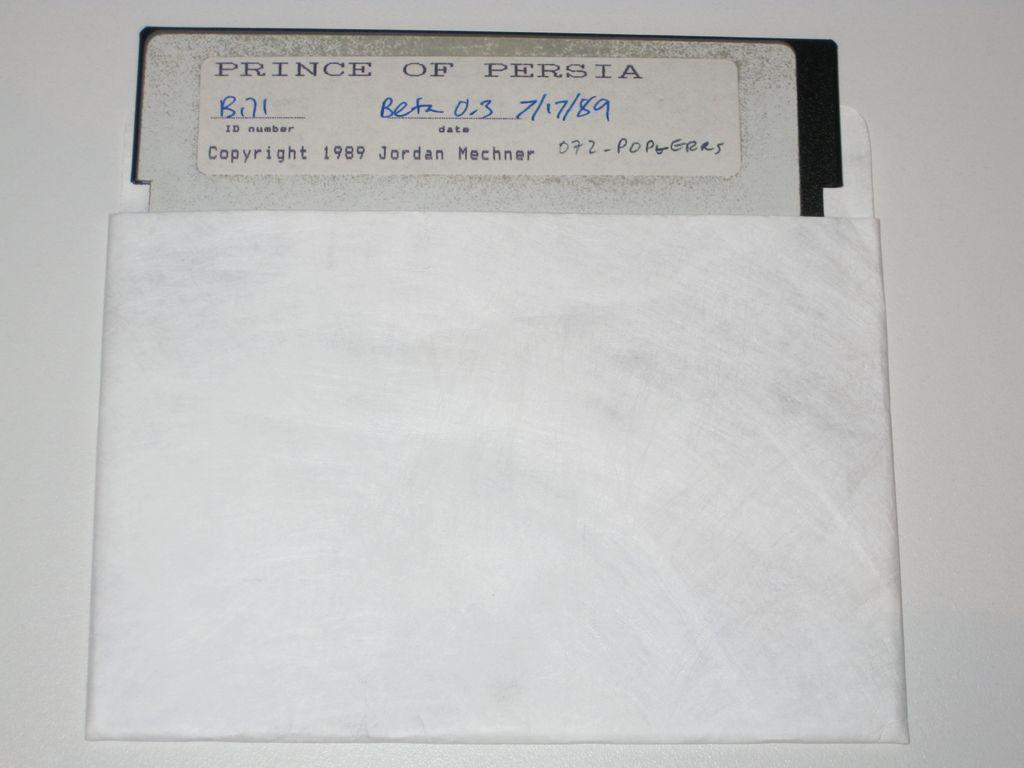<image>
Give a short and clear explanation of the subsequent image. An old floppy disc that says Prince of Persia on it. 